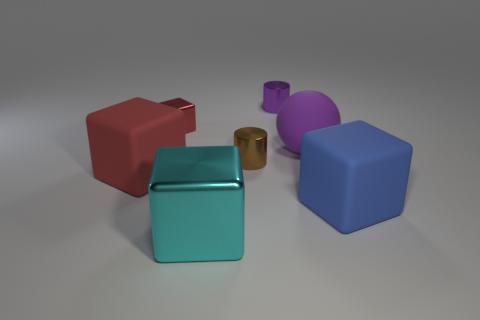Add 2 blue blocks. How many objects exist? 9 Subtract all cylinders. How many objects are left? 5 Add 7 big blue cubes. How many big blue cubes are left? 8 Add 7 small brown matte objects. How many small brown matte objects exist? 7 Subtract 0 cyan spheres. How many objects are left? 7 Subtract all tiny cubes. Subtract all small purple things. How many objects are left? 5 